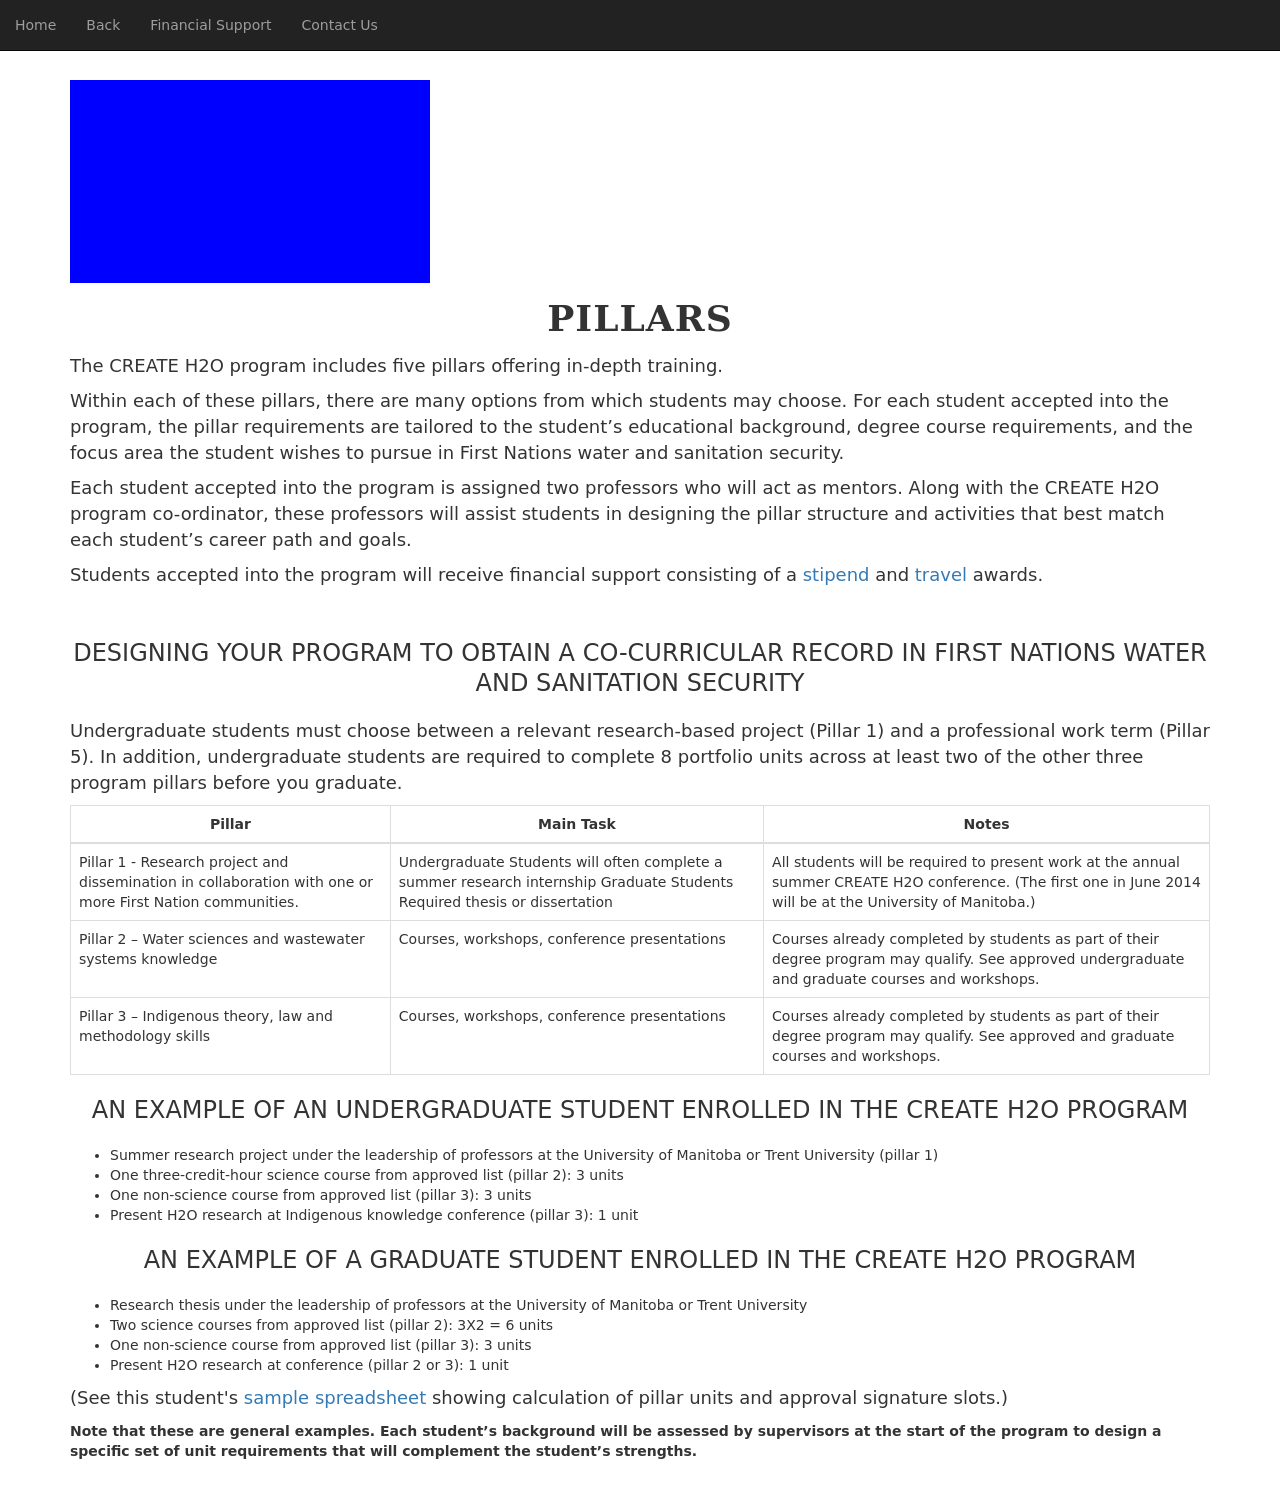How would this type of educational structure impact learner engagement and outcomes? This educational structure is likely designed to enhance learner engagement by offering a clear path through which students can progress. By dividing the curriculum into specialized pillars, students are able to see tangible milestones and achievements. This specificity can increase motivation as students are not overwhelmed by a broad spectrum of subjects but instead can focus on mastering one pillar at a time. Ultimately, this structured and segmented approach can lead to better educational outcomes by fostering deep understanding and retention of information. 
Is there a community or collaborative aspect involved in this program? Yes, the program strongly emphasizes community and collaboration, especially in projects and research that involve First Nation communities. Collaborative projects not only strengthen the learning process but also build essential skills in communication, team-work, and cultural sensitivity. By working directly with communities, students can apply theoretical knowledge in practical settings, enhancing both personal growth and community development. 